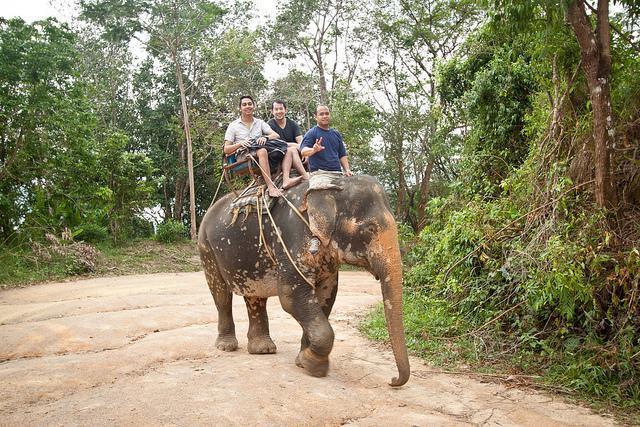How many people are in the photo?
Give a very brief answer. 2. 